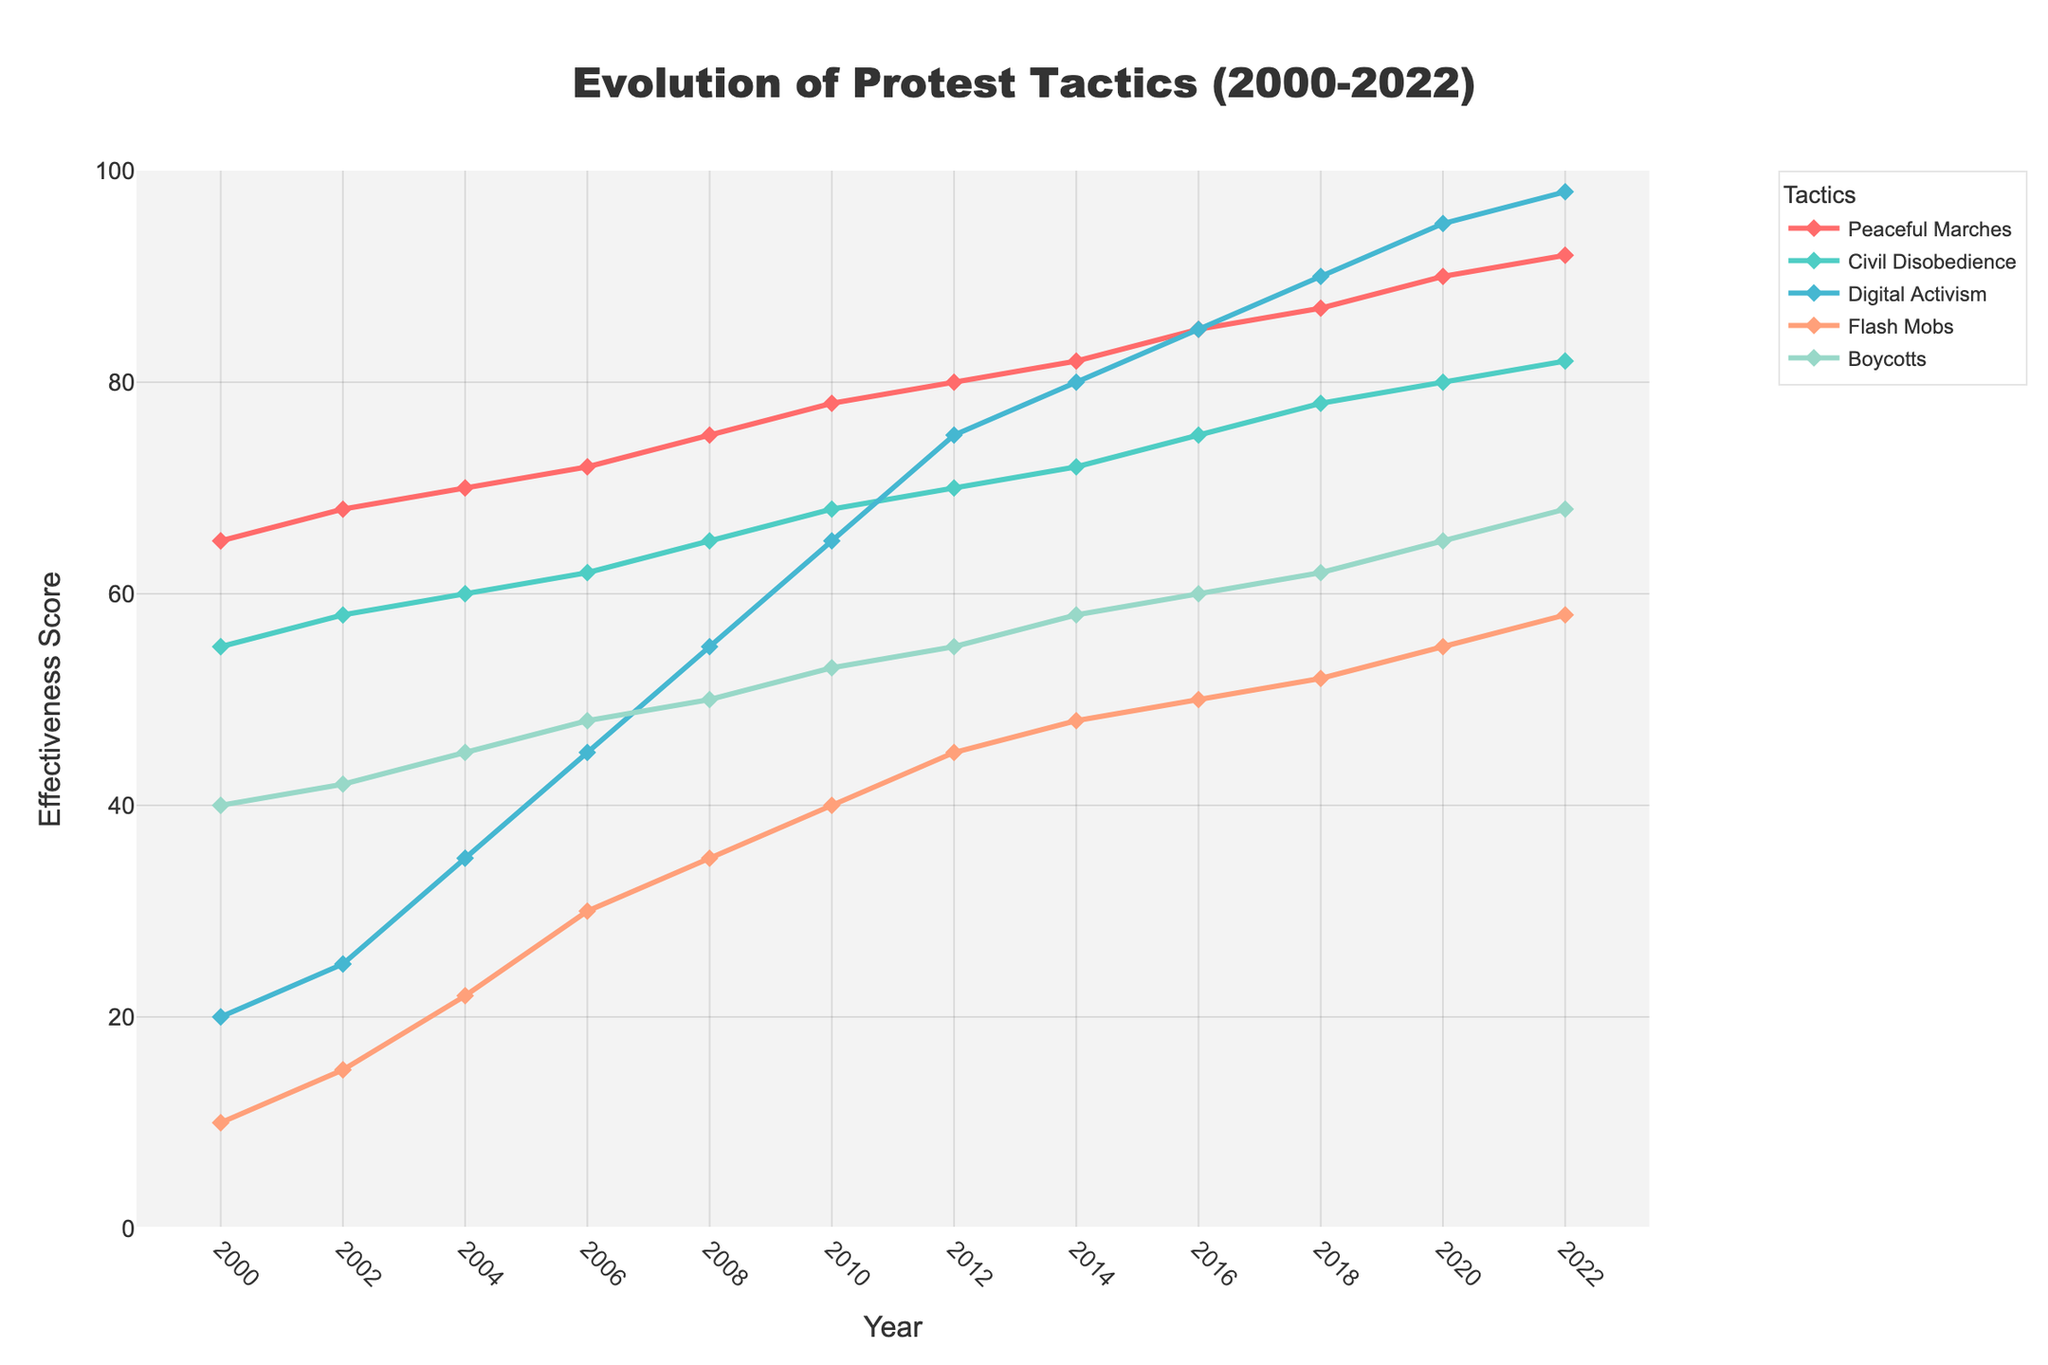What's the overall trend in the effectiveness of Digital Activism from 2000 to 2022? Look at the line representing Digital Activism on the graph, which increases steadily from 2000 to 2022.
Answer: Increasing During which years did Peaceful Marches have an effectiveness score of 80 or higher? Check the line representing Peaceful Marches and see when it crosses the 80 score mark. It starts at 80 in 2012 and increases afterward.
Answer: 2012-2022 Which tactic saw the most significant increase in effectiveness between 2008 and 2022? Calculate the difference in effectiveness scores for each tactic between 2008 and 2022, then compare these values to find the largest increase. Digital Activism increases from 55 to 98 (43 points).
Answer: Digital Activism How much more effective were Flash Mobs in 2020 compared to 2006? Compare the effectiveness score of Flash Mobs in 2020 (55) with that in 2006 (30) and find the difference: 55 - 30 = 25.
Answer: 25 points Which tactic had the lowest effectiveness score in 2000, and what was the score? Look for the lowest point on the graph in 2000. The lowest value is for Flash Mobs, which is 10.
Answer: Flash Mobs, 10 In which year did Boycotts first reach an effectiveness score above 50? Find when the line representing Boycotts crosses the 50 mark. The score is 53 in 2010, the first year it exceeds 50.
Answer: 2010 Which two tactics have the closest effectiveness scores in 2022? Compare the effectiveness scores of all tactics in 2022 and identify the smallest difference. Civil Disobedience (82) and Digital Activism (98) have a difference of 16.
Answer: Civil Disobedience and Digital Activism How did the effectiveness of Civil Disobedience change from 2000 to 2010? Compare the effectiveness scores for Civil Disobedience in 2000 (55) and 2010 (68) and note the trend. The score increased consistently over these years.
Answer: Increased What is the average effectiveness score of Boycotts in 2016? The score for Boycotts in 2016 is 60. Since it’s a single value, the average is the same as the score.
Answer: 60 Which tactic shows the least variation in effectiveness scores over the entire period? Look at how much each line fluctuates. Peaceful Marches have the least variation since they show a steady increase with minimal fluctuation.
Answer: Peaceful Marches 